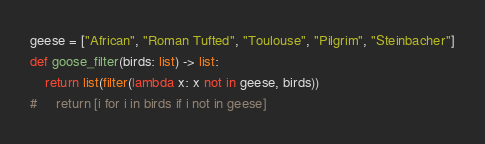Convert code to text. <code><loc_0><loc_0><loc_500><loc_500><_Python_>geese = ["African", "Roman Tufted", "Toulouse", "Pilgrim", "Steinbacher"]
def goose_filter(birds: list) -> list:
    return list(filter(lambda x: x not in geese, birds))
#     return [i for i in birds if i not in geese]</code> 